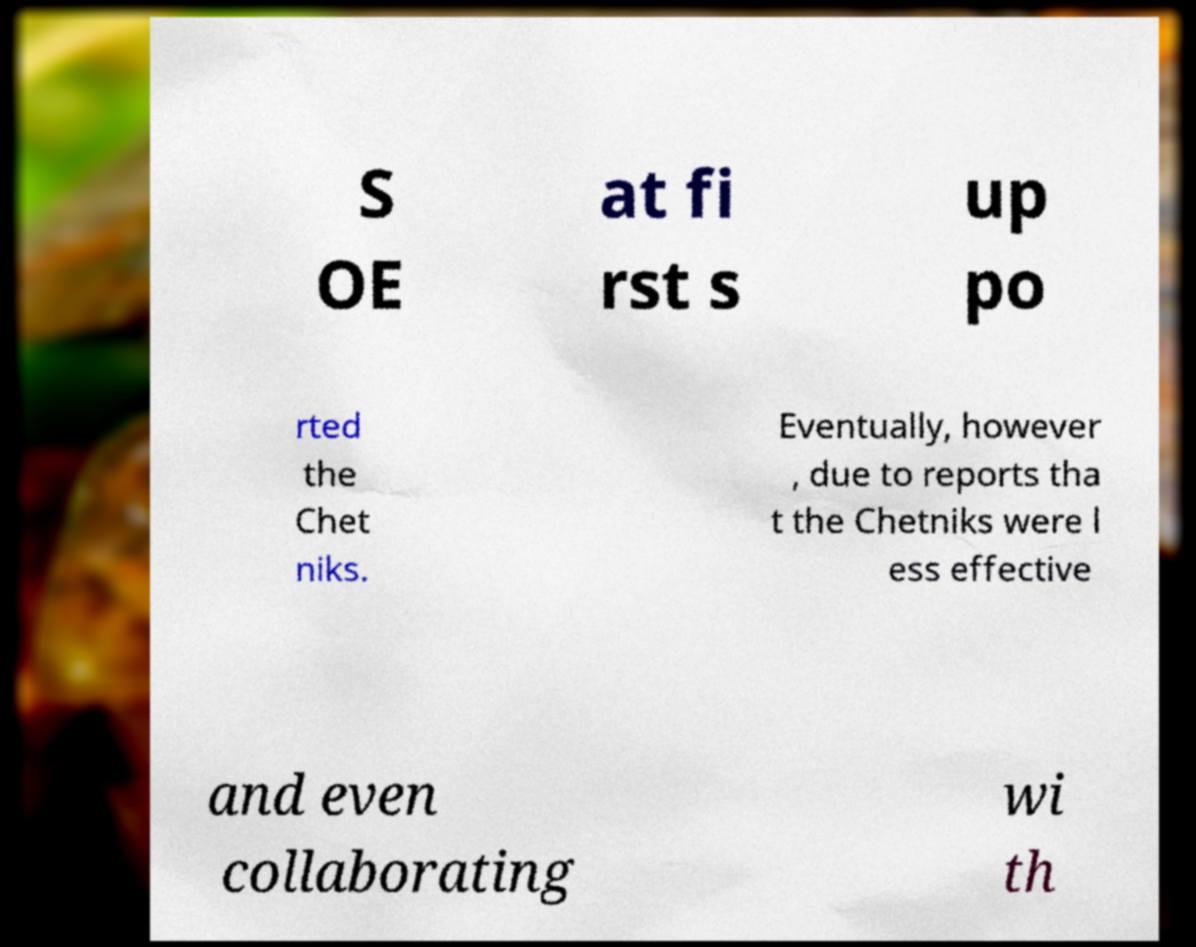For documentation purposes, I need the text within this image transcribed. Could you provide that? S OE at fi rst s up po rted the Chet niks. Eventually, however , due to reports tha t the Chetniks were l ess effective and even collaborating wi th 